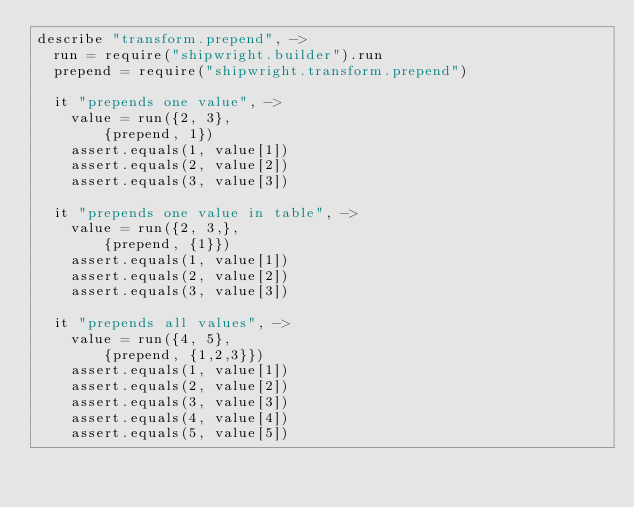Convert code to text. <code><loc_0><loc_0><loc_500><loc_500><_MoonScript_>describe "transform.prepend", ->
  run = require("shipwright.builder").run
  prepend = require("shipwright.transform.prepend")

  it "prepends one value", ->
    value = run({2, 3},
        {prepend, 1})
    assert.equals(1, value[1])
    assert.equals(2, value[2])
    assert.equals(3, value[3])

  it "prepends one value in table", ->
    value = run({2, 3,},
        {prepend, {1}})
    assert.equals(1, value[1])
    assert.equals(2, value[2])
    assert.equals(3, value[3])

  it "prepends all values", ->
    value = run({4, 5},
        {prepend, {1,2,3}})
    assert.equals(1, value[1])
    assert.equals(2, value[2])
    assert.equals(3, value[3])
    assert.equals(4, value[4])
    assert.equals(5, value[5])
</code> 